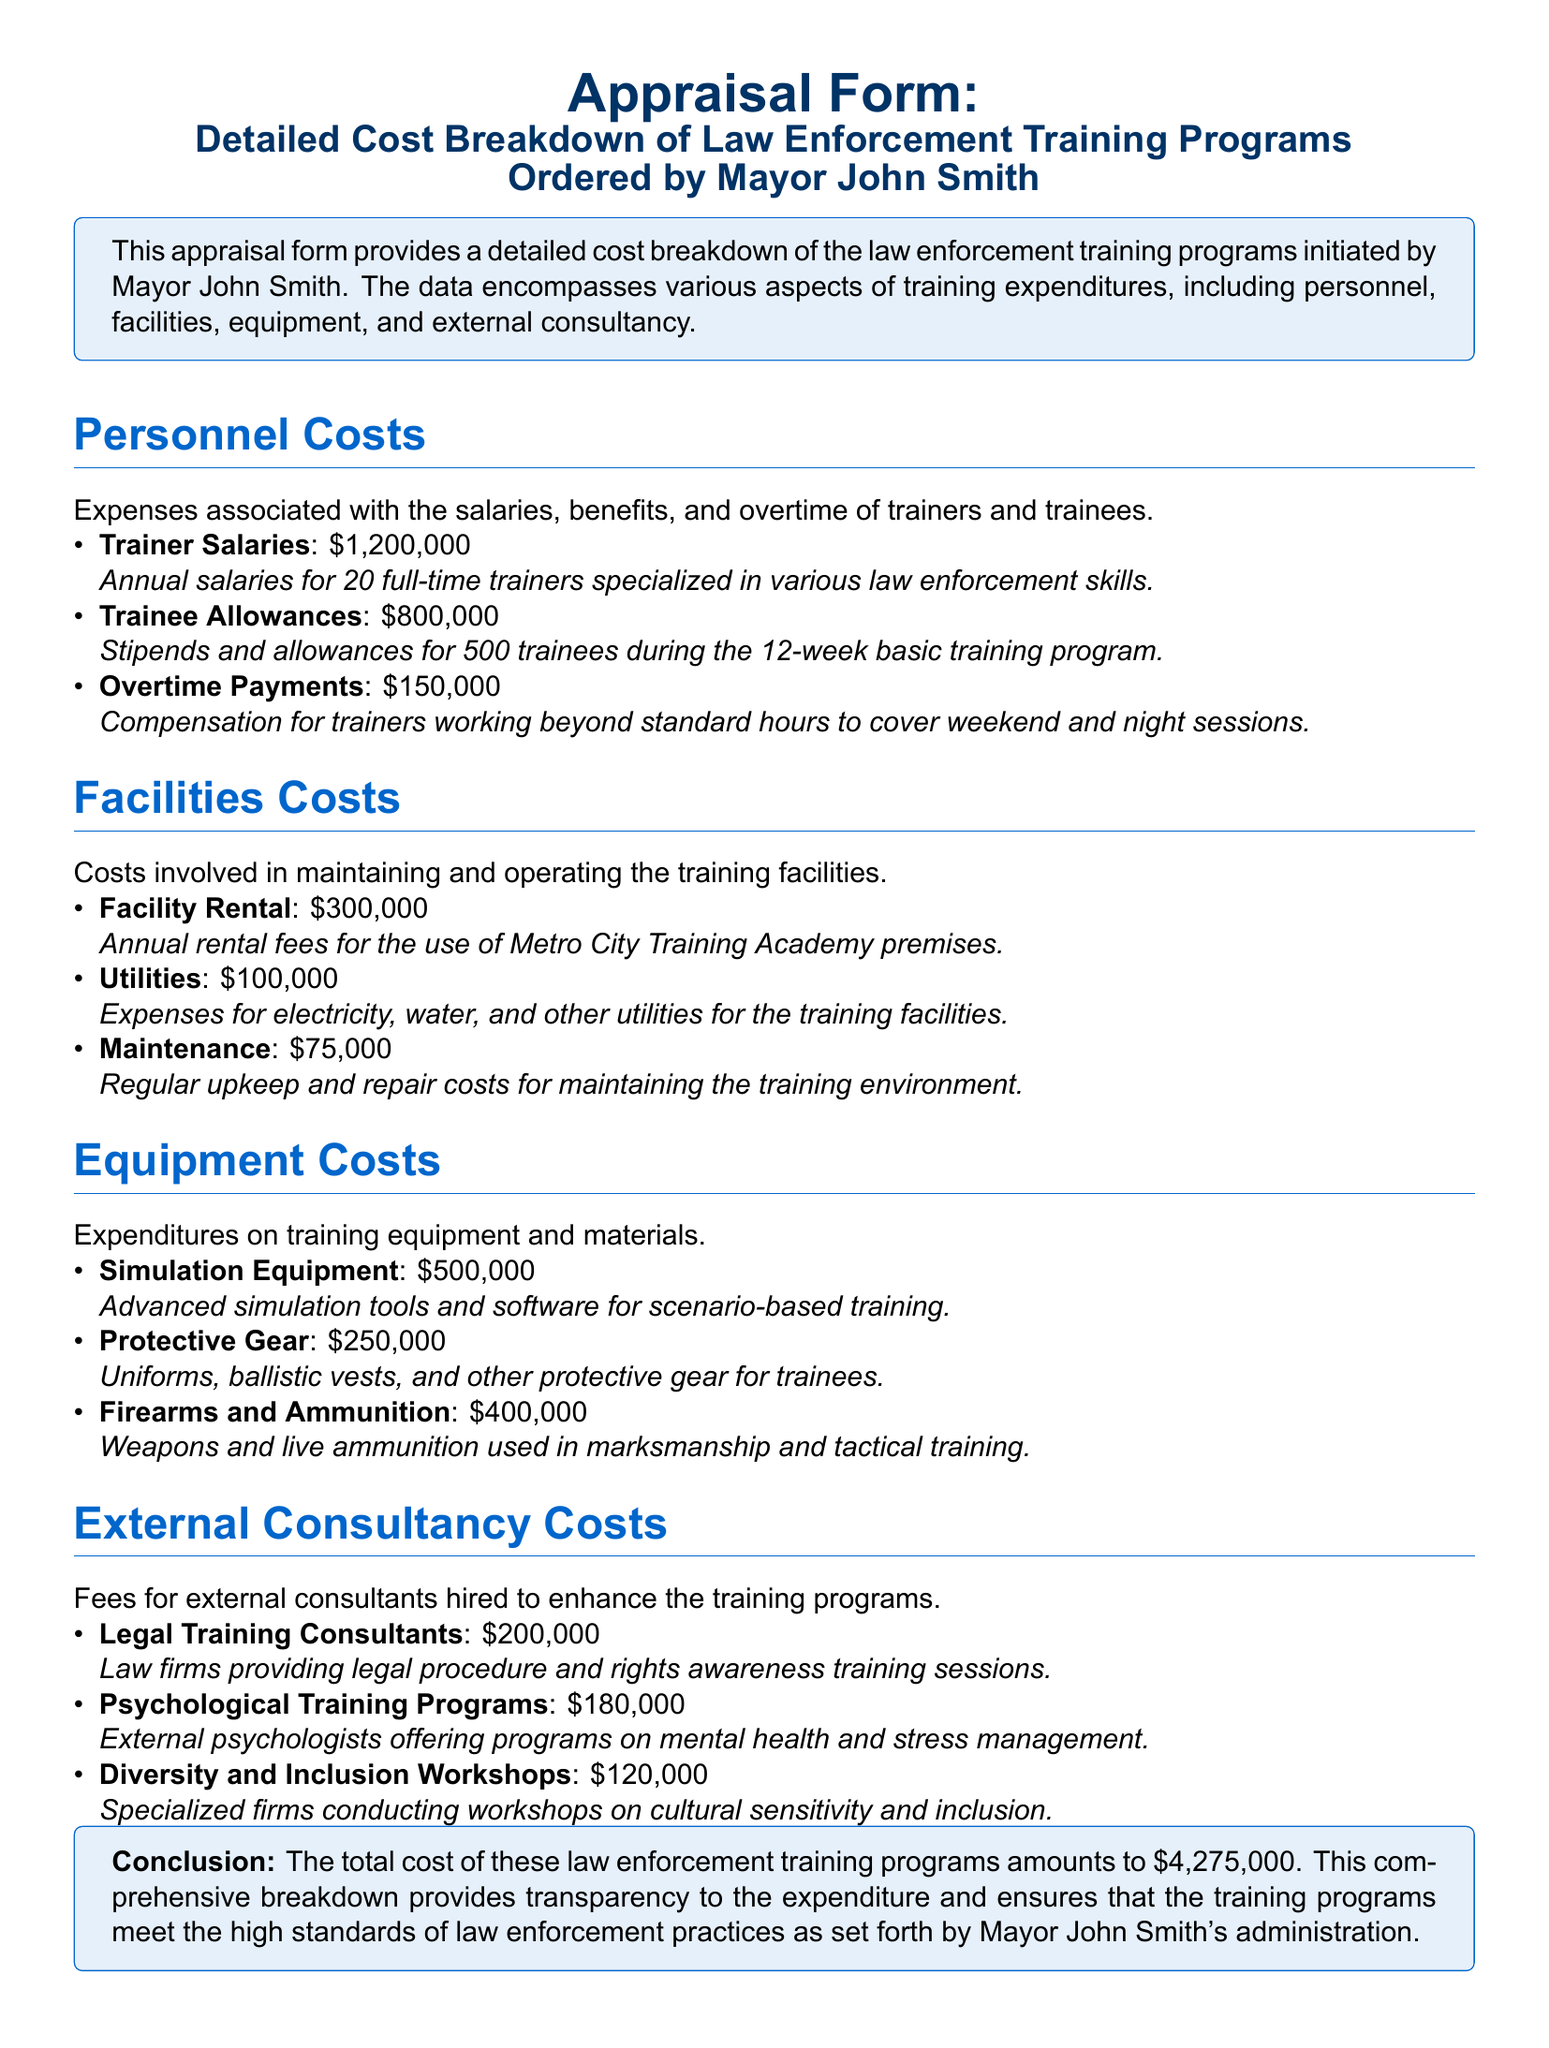What is the total cost of the law enforcement training programs? The total cost is stated in the conclusion section of the document.
Answer: $4,275,000 How many full-time trainers are employed? The document states that there are 20 full-time trainers under personnel costs.
Answer: 20 What is the cost for trainee allowances? This specific cost is detailed under personnel costs and can be found in that section.
Answer: $800,000 Which category has expenses related to law firms? The document categorizes expenses under external consultancy where law firms are mentioned.
Answer: External Consultancy Costs What is the cost for psychological training programs? The document lists this cost under external consultancy costs.
Answer: $180,000 What item has the highest cost in equipment costs? This requires analyzing the listed costs of items under equipment costs in the document.
Answer: Simulation Equipment What is the purpose of the diversity and inclusion workshops? The document describes the purpose of these workshops under external consultancy costs.
Answer: Cultural sensitivity and inclusion How much is allocated for firearms and ammunition? This is specifically mentioned in the equipment costs section of the document.
Answer: $400,000 